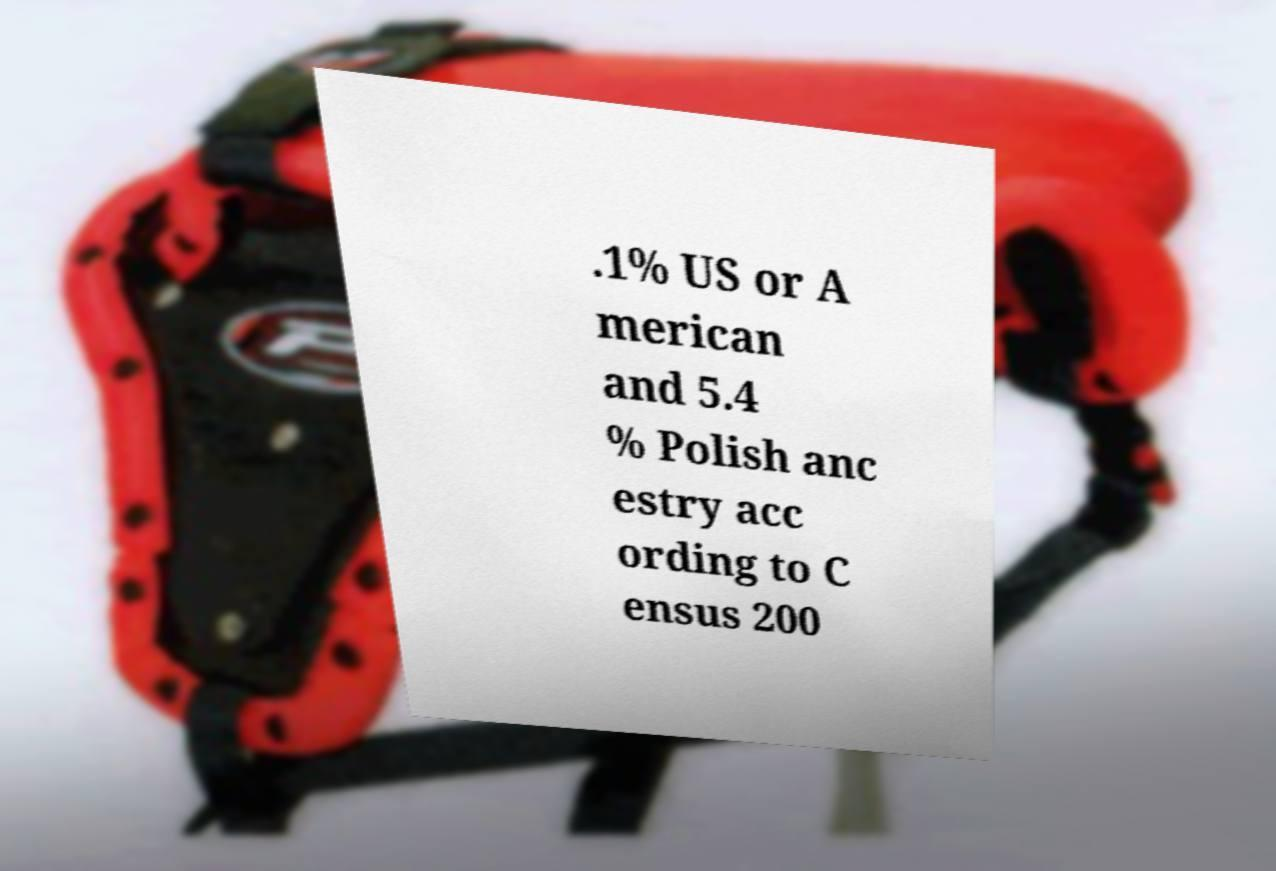Could you extract and type out the text from this image? .1% US or A merican and 5.4 % Polish anc estry acc ording to C ensus 200 